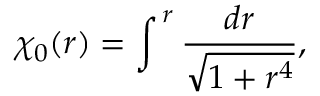<formula> <loc_0><loc_0><loc_500><loc_500>\chi _ { 0 } ( r ) = \int ^ { \, r } \frac { d r } { \sqrt { 1 + r ^ { 4 } } } ,</formula> 